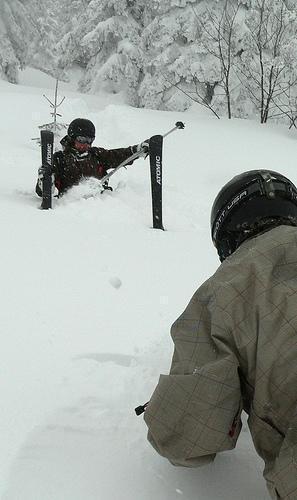How many person can be seen?
Indicate the correct choice and explain in the format: 'Answer: answer
Rationale: rationale.'
Options: Three, two, four, one. Answer: two.
Rationale: There is a man buried in the snow and another man bending over. 